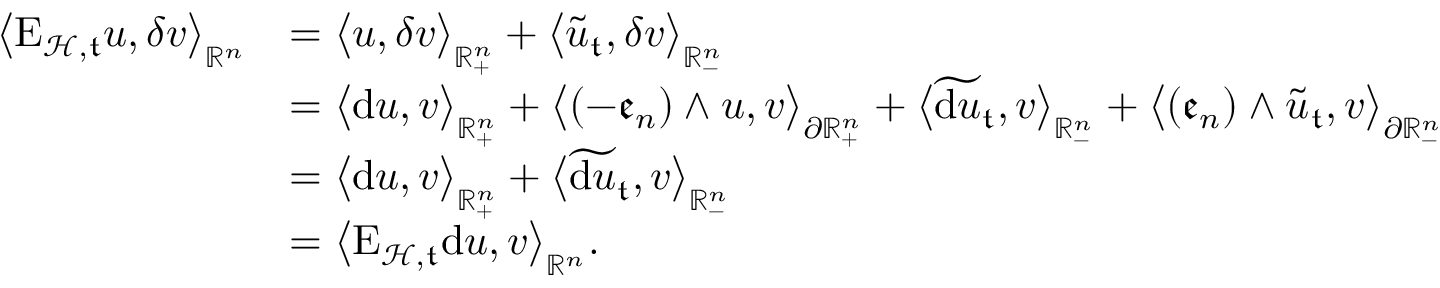<formula> <loc_0><loc_0><loc_500><loc_500>\begin{array} { r l } { \left \langle E _ { \mathcal { H } , \mathfrak { t } } u , \delta v \right \rangle _ { \mathbb { R } ^ { n } } } & { = \left \langle u , \delta v \right \rangle _ { \mathbb { R } _ { + } ^ { n } } + \left \langle \tilde { u } _ { \mathfrak { t } } , \delta v \right \rangle _ { \mathbb { R } _ { - } ^ { n } } } \\ & { = \left \langle d u , v \right \rangle _ { \mathbb { R } _ { + } ^ { n } } + \left \langle ( - \mathfrak { e } _ { n } ) \wedge u , v \right \rangle _ { \partial \mathbb { R } _ { + } ^ { n } } + \left \langle \widetilde { d u } _ { \mathfrak { t } } , v \right \rangle _ { \mathbb { R } _ { - } ^ { n } } + \left \langle ( \mathfrak { e } _ { n } ) \wedge \tilde { u } _ { \mathfrak { t } } , v \right \rangle _ { \partial \mathbb { R } _ { - } ^ { n } } } \\ & { = \left \langle d u , v \right \rangle _ { \mathbb { R } _ { + } ^ { n } } + \left \langle \widetilde { d u } _ { \mathfrak { t } } , v \right \rangle _ { \mathbb { R } _ { - } ^ { n } } } \\ & { = \left \langle E _ { \mathcal { H } , \mathfrak { t } } d u , v \right \rangle _ { \mathbb { R } ^ { n } } . } \end{array}</formula> 